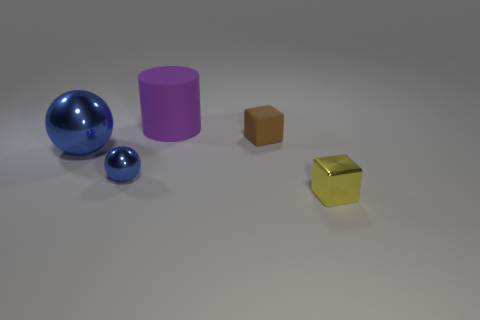There is a blue metal object on the right side of the big shiny ball; does it have the same size as the purple rubber cylinder left of the yellow metallic object?
Make the answer very short. No. There is a brown block; is it the same size as the object behind the brown object?
Give a very brief answer. No. There is a yellow metallic thing that is the same shape as the brown rubber object; what size is it?
Make the answer very short. Small. Are there any other things that are the same shape as the large purple thing?
Offer a terse response. No. What is the color of the tiny thing that is the same shape as the large blue metal thing?
Give a very brief answer. Blue. The tiny sphere that is made of the same material as the big blue ball is what color?
Your answer should be very brief. Blue. Are there an equal number of matte cylinders in front of the big ball and red metallic blocks?
Offer a very short reply. Yes. Does the matte object that is to the right of the matte cylinder have the same size as the yellow shiny thing?
Your answer should be very brief. Yes. There is another cube that is the same size as the yellow metallic cube; what color is it?
Provide a succinct answer. Brown. There is a rubber cylinder on the left side of the rubber object that is in front of the purple rubber cylinder; are there any blue things that are to the right of it?
Provide a succinct answer. No. 